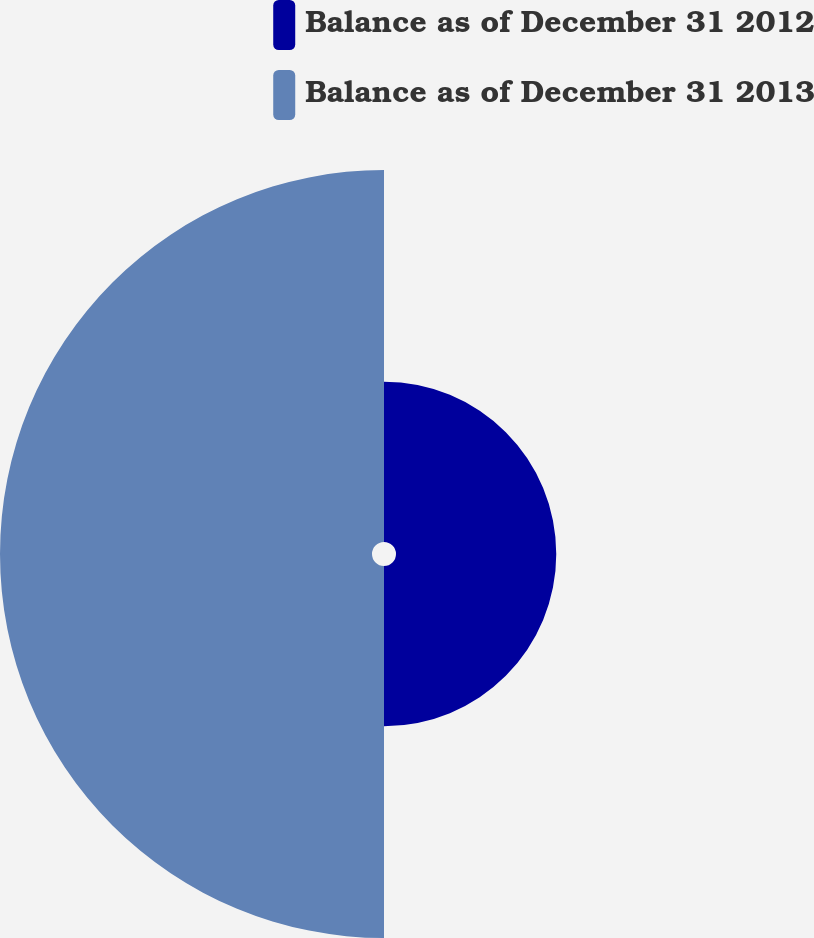Convert chart. <chart><loc_0><loc_0><loc_500><loc_500><pie_chart><fcel>Balance as of December 31 2012<fcel>Balance as of December 31 2013<nl><fcel>30.11%<fcel>69.89%<nl></chart> 